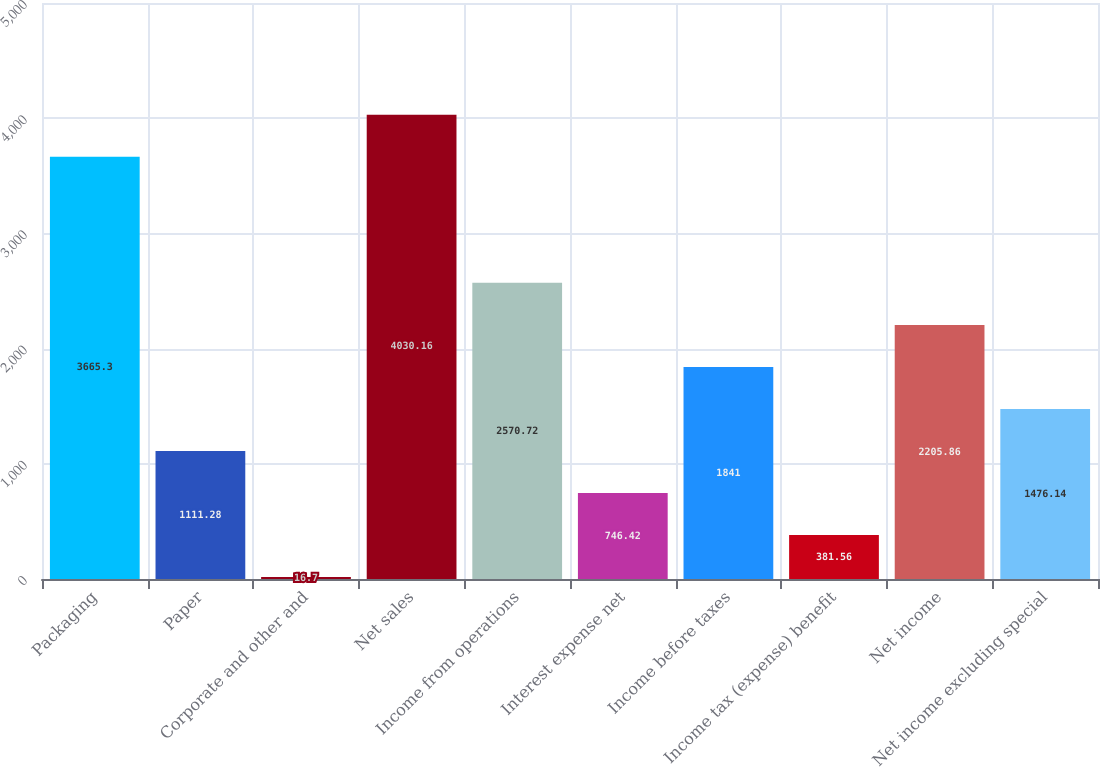<chart> <loc_0><loc_0><loc_500><loc_500><bar_chart><fcel>Packaging<fcel>Paper<fcel>Corporate and other and<fcel>Net sales<fcel>Income from operations<fcel>Interest expense net<fcel>Income before taxes<fcel>Income tax (expense) benefit<fcel>Net income<fcel>Net income excluding special<nl><fcel>3665.3<fcel>1111.28<fcel>16.7<fcel>4030.16<fcel>2570.72<fcel>746.42<fcel>1841<fcel>381.56<fcel>2205.86<fcel>1476.14<nl></chart> 